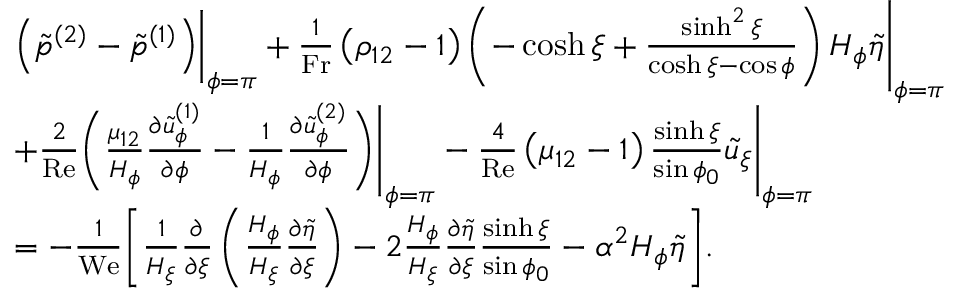Convert formula to latex. <formula><loc_0><loc_0><loc_500><loc_500>\begin{array} { r l } & { \begin{array} { r l } & { \left ( \tilde { p } ^ { ( 2 ) } - \tilde { p } ^ { ( 1 ) } \right ) \left | _ { \phi = \pi } + \frac { 1 } { F r } \left ( \rho _ { 1 2 } - 1 \right ) \left ( - \cosh \xi + \frac { \sinh ^ { 2 } \xi } { \cosh \xi - \cos \phi } \right ) H _ { \phi } \tilde { \eta } \right | _ { \phi = \pi } } \\ & { + \frac { 2 } { R e } \left ( \frac { \mu _ { 1 2 } } { H _ { \phi } } \frac { \partial \tilde { u } _ { \phi } ^ { ( 1 ) } } { \partial \phi } - \frac { 1 } { H _ { \phi } } \frac { \partial \tilde { u } _ { \phi } ^ { ( 2 ) } } { \partial \phi } \right ) \left | _ { \phi = \pi } - \frac { 4 } { R e } \left ( \mu _ { 1 2 } - 1 \right ) \frac { \sinh \xi } { \sin \phi _ { 0 } } \tilde { u } _ { \xi } \right | _ { \phi = \pi } } \\ & { = - \frac { 1 } { W e } \left [ \frac { 1 } { H _ { \xi } } \frac { \partial } { \partial \xi } \left ( \frac { H _ { \phi } } { H _ { \xi } } \frac { \partial \tilde { \eta } } { \partial \xi } \right ) - 2 \frac { H _ { \phi } } { H _ { \xi } } \frac { \partial \tilde { \eta } } { \partial \xi } \frac { \sinh \xi } { \sin \phi _ { 0 } } - \alpha ^ { 2 } H _ { \phi } \tilde { \eta } \right ] . } \end{array} } \end{array}</formula> 